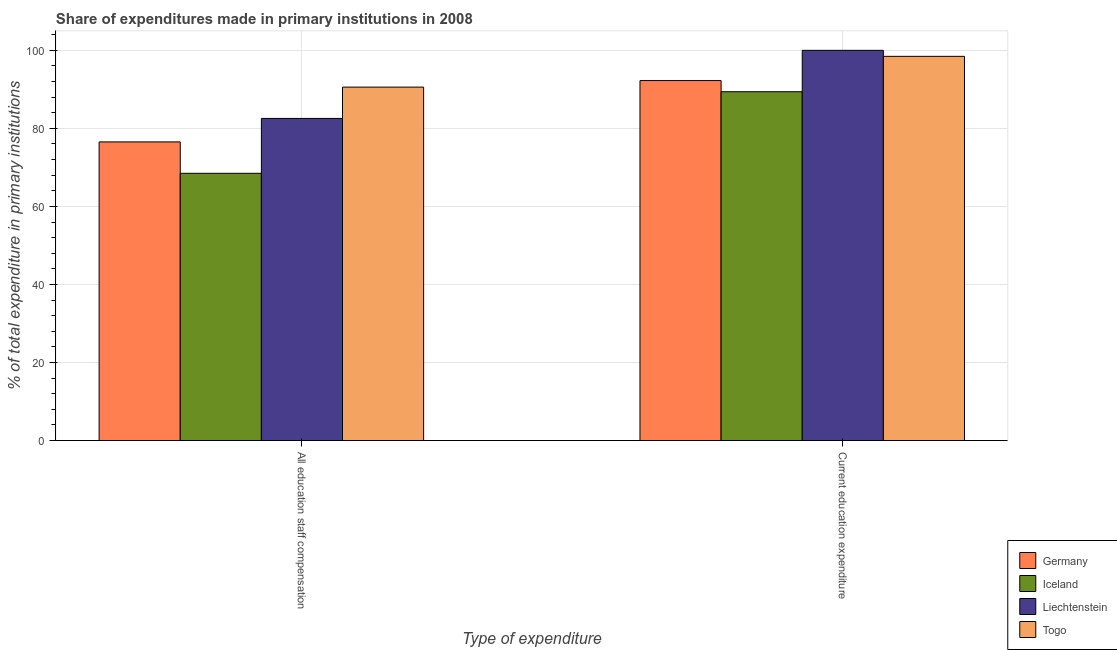How many different coloured bars are there?
Provide a succinct answer. 4. What is the label of the 1st group of bars from the left?
Provide a succinct answer. All education staff compensation. What is the expenditure in education in Iceland?
Give a very brief answer. 89.4. Across all countries, what is the minimum expenditure in education?
Offer a terse response. 89.4. In which country was the expenditure in education maximum?
Offer a very short reply. Liechtenstein. In which country was the expenditure in staff compensation minimum?
Offer a terse response. Iceland. What is the total expenditure in education in the graph?
Give a very brief answer. 380.11. What is the difference between the expenditure in education in Iceland and that in Togo?
Ensure brevity in your answer.  -9.06. What is the difference between the expenditure in education in Togo and the expenditure in staff compensation in Iceland?
Offer a terse response. 29.97. What is the average expenditure in staff compensation per country?
Offer a very short reply. 79.54. What is the difference between the expenditure in education and expenditure in staff compensation in Germany?
Provide a short and direct response. 15.71. What is the ratio of the expenditure in staff compensation in Iceland to that in Germany?
Give a very brief answer. 0.89. In how many countries, is the expenditure in education greater than the average expenditure in education taken over all countries?
Your answer should be very brief. 2. What does the 1st bar from the right in All education staff compensation represents?
Offer a terse response. Togo. How many countries are there in the graph?
Provide a short and direct response. 4. What is the difference between two consecutive major ticks on the Y-axis?
Your answer should be compact. 20. Are the values on the major ticks of Y-axis written in scientific E-notation?
Ensure brevity in your answer.  No. Does the graph contain any zero values?
Your answer should be compact. No. Where does the legend appear in the graph?
Provide a succinct answer. Bottom right. How many legend labels are there?
Your response must be concise. 4. What is the title of the graph?
Ensure brevity in your answer.  Share of expenditures made in primary institutions in 2008. What is the label or title of the X-axis?
Provide a succinct answer. Type of expenditure. What is the label or title of the Y-axis?
Make the answer very short. % of total expenditure in primary institutions. What is the % of total expenditure in primary institutions of Germany in All education staff compensation?
Your answer should be compact. 76.54. What is the % of total expenditure in primary institutions in Iceland in All education staff compensation?
Your response must be concise. 68.49. What is the % of total expenditure in primary institutions of Liechtenstein in All education staff compensation?
Your response must be concise. 82.55. What is the % of total expenditure in primary institutions of Togo in All education staff compensation?
Your answer should be compact. 90.57. What is the % of total expenditure in primary institutions in Germany in Current education expenditure?
Provide a succinct answer. 92.25. What is the % of total expenditure in primary institutions of Iceland in Current education expenditure?
Your answer should be very brief. 89.4. What is the % of total expenditure in primary institutions in Liechtenstein in Current education expenditure?
Your answer should be very brief. 100. What is the % of total expenditure in primary institutions of Togo in Current education expenditure?
Offer a very short reply. 98.46. Across all Type of expenditure, what is the maximum % of total expenditure in primary institutions of Germany?
Your answer should be compact. 92.25. Across all Type of expenditure, what is the maximum % of total expenditure in primary institutions of Iceland?
Your response must be concise. 89.4. Across all Type of expenditure, what is the maximum % of total expenditure in primary institutions in Liechtenstein?
Provide a short and direct response. 100. Across all Type of expenditure, what is the maximum % of total expenditure in primary institutions of Togo?
Give a very brief answer. 98.46. Across all Type of expenditure, what is the minimum % of total expenditure in primary institutions of Germany?
Keep it short and to the point. 76.54. Across all Type of expenditure, what is the minimum % of total expenditure in primary institutions of Iceland?
Give a very brief answer. 68.49. Across all Type of expenditure, what is the minimum % of total expenditure in primary institutions in Liechtenstein?
Ensure brevity in your answer.  82.55. Across all Type of expenditure, what is the minimum % of total expenditure in primary institutions in Togo?
Offer a terse response. 90.57. What is the total % of total expenditure in primary institutions in Germany in the graph?
Give a very brief answer. 168.79. What is the total % of total expenditure in primary institutions in Iceland in the graph?
Keep it short and to the point. 157.88. What is the total % of total expenditure in primary institutions of Liechtenstein in the graph?
Ensure brevity in your answer.  182.55. What is the total % of total expenditure in primary institutions in Togo in the graph?
Make the answer very short. 189.03. What is the difference between the % of total expenditure in primary institutions in Germany in All education staff compensation and that in Current education expenditure?
Offer a terse response. -15.71. What is the difference between the % of total expenditure in primary institutions in Iceland in All education staff compensation and that in Current education expenditure?
Give a very brief answer. -20.91. What is the difference between the % of total expenditure in primary institutions in Liechtenstein in All education staff compensation and that in Current education expenditure?
Your answer should be compact. -17.45. What is the difference between the % of total expenditure in primary institutions of Togo in All education staff compensation and that in Current education expenditure?
Ensure brevity in your answer.  -7.89. What is the difference between the % of total expenditure in primary institutions in Germany in All education staff compensation and the % of total expenditure in primary institutions in Iceland in Current education expenditure?
Provide a short and direct response. -12.86. What is the difference between the % of total expenditure in primary institutions in Germany in All education staff compensation and the % of total expenditure in primary institutions in Liechtenstein in Current education expenditure?
Offer a very short reply. -23.46. What is the difference between the % of total expenditure in primary institutions in Germany in All education staff compensation and the % of total expenditure in primary institutions in Togo in Current education expenditure?
Make the answer very short. -21.92. What is the difference between the % of total expenditure in primary institutions of Iceland in All education staff compensation and the % of total expenditure in primary institutions of Liechtenstein in Current education expenditure?
Offer a very short reply. -31.51. What is the difference between the % of total expenditure in primary institutions in Iceland in All education staff compensation and the % of total expenditure in primary institutions in Togo in Current education expenditure?
Ensure brevity in your answer.  -29.97. What is the difference between the % of total expenditure in primary institutions of Liechtenstein in All education staff compensation and the % of total expenditure in primary institutions of Togo in Current education expenditure?
Offer a terse response. -15.91. What is the average % of total expenditure in primary institutions in Germany per Type of expenditure?
Offer a terse response. 84.4. What is the average % of total expenditure in primary institutions of Iceland per Type of expenditure?
Keep it short and to the point. 78.94. What is the average % of total expenditure in primary institutions of Liechtenstein per Type of expenditure?
Keep it short and to the point. 91.27. What is the average % of total expenditure in primary institutions of Togo per Type of expenditure?
Your response must be concise. 94.52. What is the difference between the % of total expenditure in primary institutions of Germany and % of total expenditure in primary institutions of Iceland in All education staff compensation?
Make the answer very short. 8.05. What is the difference between the % of total expenditure in primary institutions in Germany and % of total expenditure in primary institutions in Liechtenstein in All education staff compensation?
Provide a short and direct response. -6.01. What is the difference between the % of total expenditure in primary institutions of Germany and % of total expenditure in primary institutions of Togo in All education staff compensation?
Provide a short and direct response. -14.03. What is the difference between the % of total expenditure in primary institutions of Iceland and % of total expenditure in primary institutions of Liechtenstein in All education staff compensation?
Keep it short and to the point. -14.06. What is the difference between the % of total expenditure in primary institutions in Iceland and % of total expenditure in primary institutions in Togo in All education staff compensation?
Ensure brevity in your answer.  -22.09. What is the difference between the % of total expenditure in primary institutions in Liechtenstein and % of total expenditure in primary institutions in Togo in All education staff compensation?
Provide a succinct answer. -8.02. What is the difference between the % of total expenditure in primary institutions in Germany and % of total expenditure in primary institutions in Iceland in Current education expenditure?
Make the answer very short. 2.86. What is the difference between the % of total expenditure in primary institutions in Germany and % of total expenditure in primary institutions in Liechtenstein in Current education expenditure?
Ensure brevity in your answer.  -7.75. What is the difference between the % of total expenditure in primary institutions of Germany and % of total expenditure in primary institutions of Togo in Current education expenditure?
Make the answer very short. -6.21. What is the difference between the % of total expenditure in primary institutions in Iceland and % of total expenditure in primary institutions in Liechtenstein in Current education expenditure?
Provide a succinct answer. -10.6. What is the difference between the % of total expenditure in primary institutions of Iceland and % of total expenditure in primary institutions of Togo in Current education expenditure?
Make the answer very short. -9.06. What is the difference between the % of total expenditure in primary institutions of Liechtenstein and % of total expenditure in primary institutions of Togo in Current education expenditure?
Provide a short and direct response. 1.54. What is the ratio of the % of total expenditure in primary institutions of Germany in All education staff compensation to that in Current education expenditure?
Your answer should be compact. 0.83. What is the ratio of the % of total expenditure in primary institutions of Iceland in All education staff compensation to that in Current education expenditure?
Keep it short and to the point. 0.77. What is the ratio of the % of total expenditure in primary institutions of Liechtenstein in All education staff compensation to that in Current education expenditure?
Offer a terse response. 0.83. What is the ratio of the % of total expenditure in primary institutions in Togo in All education staff compensation to that in Current education expenditure?
Offer a terse response. 0.92. What is the difference between the highest and the second highest % of total expenditure in primary institutions in Germany?
Provide a short and direct response. 15.71. What is the difference between the highest and the second highest % of total expenditure in primary institutions in Iceland?
Offer a terse response. 20.91. What is the difference between the highest and the second highest % of total expenditure in primary institutions in Liechtenstein?
Ensure brevity in your answer.  17.45. What is the difference between the highest and the second highest % of total expenditure in primary institutions in Togo?
Ensure brevity in your answer.  7.89. What is the difference between the highest and the lowest % of total expenditure in primary institutions of Germany?
Your answer should be very brief. 15.71. What is the difference between the highest and the lowest % of total expenditure in primary institutions of Iceland?
Make the answer very short. 20.91. What is the difference between the highest and the lowest % of total expenditure in primary institutions in Liechtenstein?
Provide a succinct answer. 17.45. What is the difference between the highest and the lowest % of total expenditure in primary institutions in Togo?
Provide a succinct answer. 7.89. 